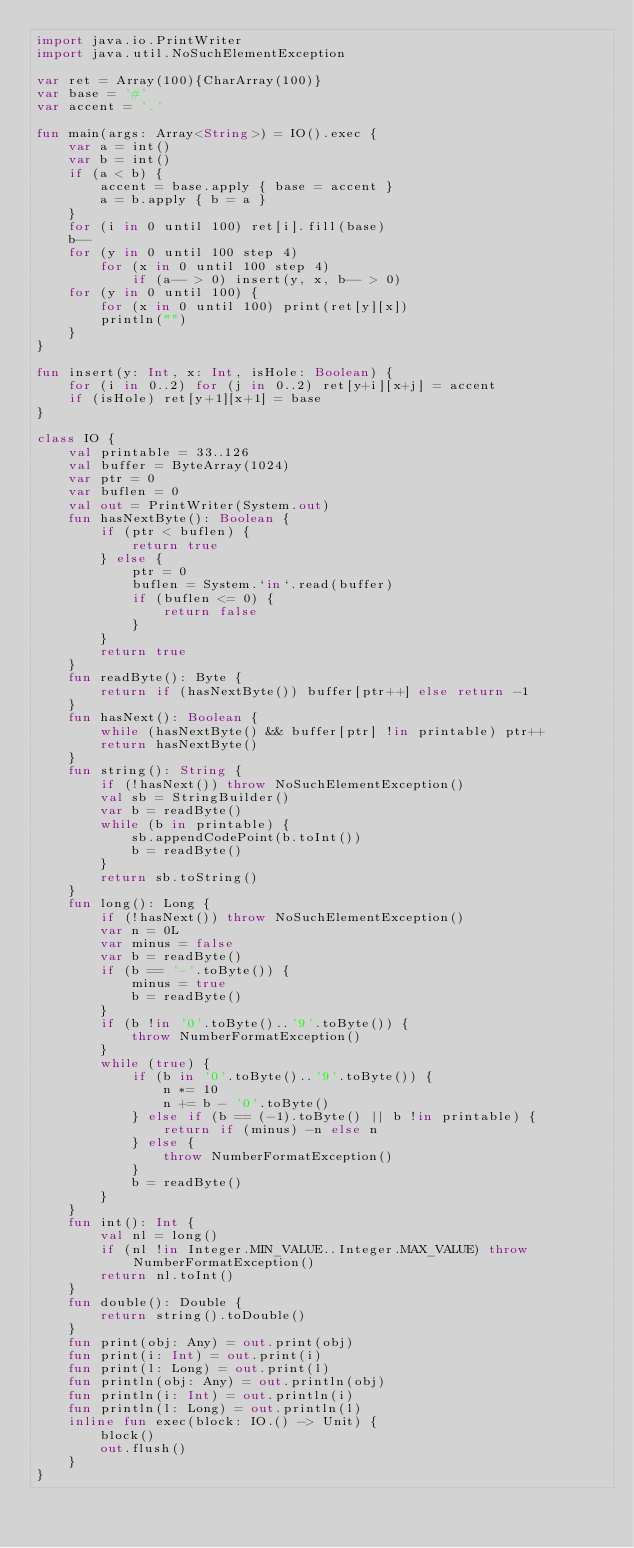Convert code to text. <code><loc_0><loc_0><loc_500><loc_500><_Kotlin_>import java.io.PrintWriter
import java.util.NoSuchElementException

var ret = Array(100){CharArray(100)}
var base = '#'
var accent = '.'

fun main(args: Array<String>) = IO().exec {
    var a = int()
    var b = int()
    if (a < b) {
        accent = base.apply { base = accent }
        a = b.apply { b = a }
    }
    for (i in 0 until 100) ret[i].fill(base)
    b--
    for (y in 0 until 100 step 4)
        for (x in 0 until 100 step 4)
            if (a-- > 0) insert(y, x, b-- > 0)
    for (y in 0 until 100) {
        for (x in 0 until 100) print(ret[y][x])
        println("")
    }
}

fun insert(y: Int, x: Int, isHole: Boolean) {
    for (i in 0..2) for (j in 0..2) ret[y+i][x+j] = accent
    if (isHole) ret[y+1][x+1] = base
}

class IO {
    val printable = 33..126
    val buffer = ByteArray(1024)
    var ptr = 0
    var buflen = 0
    val out = PrintWriter(System.out)
    fun hasNextByte(): Boolean {
        if (ptr < buflen) {
            return true
        } else {
            ptr = 0
            buflen = System.`in`.read(buffer)
            if (buflen <= 0) {
                return false
            }
        }
        return true
    }
    fun readByte(): Byte {
        return if (hasNextByte()) buffer[ptr++] else return -1
    }
    fun hasNext(): Boolean {
        while (hasNextByte() && buffer[ptr] !in printable) ptr++
        return hasNextByte()
    }
    fun string(): String {
        if (!hasNext()) throw NoSuchElementException()
        val sb = StringBuilder()
        var b = readByte()
        while (b in printable) {
            sb.appendCodePoint(b.toInt())
            b = readByte()
        }
        return sb.toString()
    }
    fun long(): Long {
        if (!hasNext()) throw NoSuchElementException()
        var n = 0L
        var minus = false
        var b = readByte()
        if (b == '-'.toByte()) {
            minus = true
            b = readByte()
        }
        if (b !in '0'.toByte()..'9'.toByte()) {
            throw NumberFormatException()
        }
        while (true) {
            if (b in '0'.toByte()..'9'.toByte()) {
                n *= 10
                n += b - '0'.toByte()
            } else if (b == (-1).toByte() || b !in printable) {
                return if (minus) -n else n
            } else {
                throw NumberFormatException()
            }
            b = readByte()
        }
    }
    fun int(): Int {
        val nl = long()
        if (nl !in Integer.MIN_VALUE..Integer.MAX_VALUE) throw NumberFormatException()
        return nl.toInt()
    }
    fun double(): Double {
        return string().toDouble()
    }
    fun print(obj: Any) = out.print(obj)
    fun print(i: Int) = out.print(i)
    fun print(l: Long) = out.print(l)
    fun println(obj: Any) = out.println(obj)
    fun println(i: Int) = out.println(i)
    fun println(l: Long) = out.println(l)
    inline fun exec(block: IO.() -> Unit) {
        block()
        out.flush()
    }
}</code> 